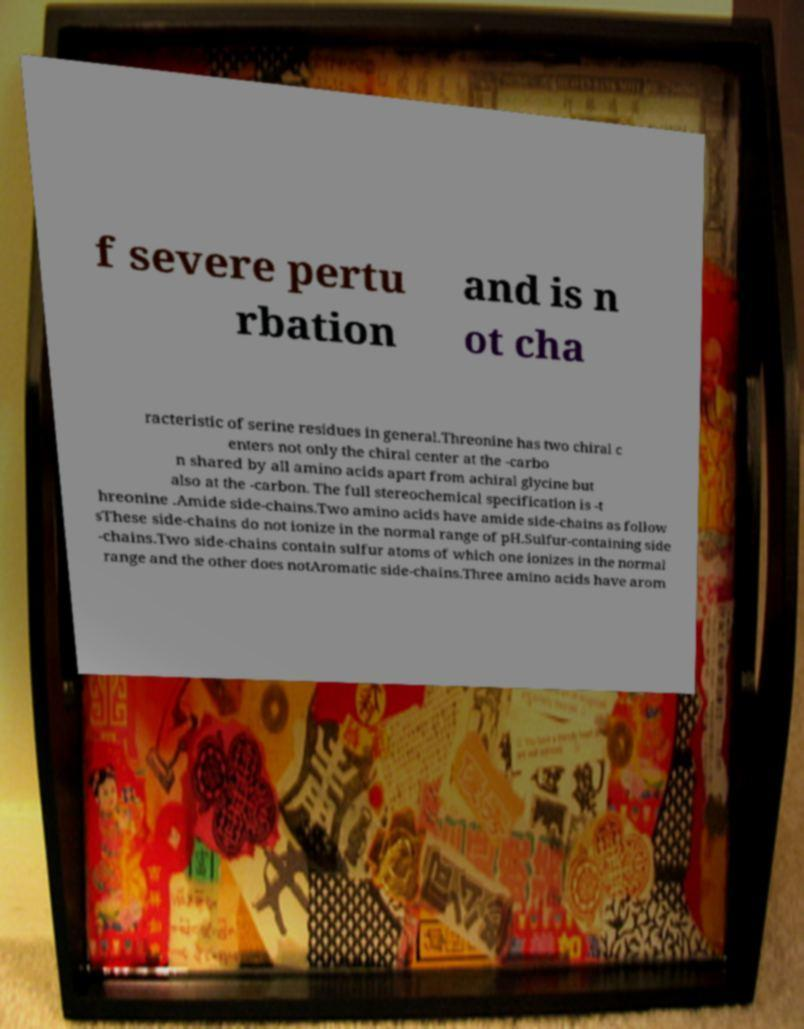There's text embedded in this image that I need extracted. Can you transcribe it verbatim? f severe pertu rbation and is n ot cha racteristic of serine residues in general.Threonine has two chiral c enters not only the chiral center at the -carbo n shared by all amino acids apart from achiral glycine but also at the -carbon. The full stereochemical specification is -t hreonine .Amide side-chains.Two amino acids have amide side-chains as follow sThese side-chains do not ionize in the normal range of pH.Sulfur-containing side -chains.Two side-chains contain sulfur atoms of which one ionizes in the normal range and the other does notAromatic side-chains.Three amino acids have arom 